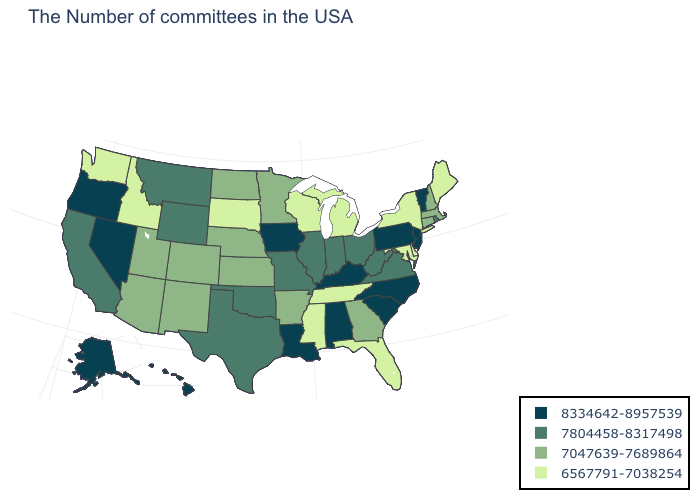Does Minnesota have the same value as Oregon?
Write a very short answer. No. What is the value of Rhode Island?
Short answer required. 7804458-8317498. Which states have the lowest value in the USA?
Concise answer only. Maine, New York, Delaware, Maryland, Florida, Michigan, Tennessee, Wisconsin, Mississippi, South Dakota, Idaho, Washington. Does the first symbol in the legend represent the smallest category?
Answer briefly. No. Name the states that have a value in the range 7804458-8317498?
Answer briefly. Rhode Island, Virginia, West Virginia, Ohio, Indiana, Illinois, Missouri, Oklahoma, Texas, Wyoming, Montana, California. Does Maine have the highest value in the USA?
Quick response, please. No. Among the states that border Florida , does Alabama have the lowest value?
Concise answer only. No. Name the states that have a value in the range 7047639-7689864?
Give a very brief answer. Massachusetts, New Hampshire, Connecticut, Georgia, Arkansas, Minnesota, Kansas, Nebraska, North Dakota, Colorado, New Mexico, Utah, Arizona. Among the states that border Maryland , which have the highest value?
Quick response, please. Pennsylvania. Which states hav the highest value in the Northeast?
Quick response, please. Vermont, New Jersey, Pennsylvania. Does Indiana have the highest value in the MidWest?
Be succinct. No. Among the states that border Oregon , does Nevada have the highest value?
Quick response, please. Yes. What is the value of Texas?
Concise answer only. 7804458-8317498. What is the value of Ohio?
Answer briefly. 7804458-8317498. Name the states that have a value in the range 6567791-7038254?
Keep it brief. Maine, New York, Delaware, Maryland, Florida, Michigan, Tennessee, Wisconsin, Mississippi, South Dakota, Idaho, Washington. 